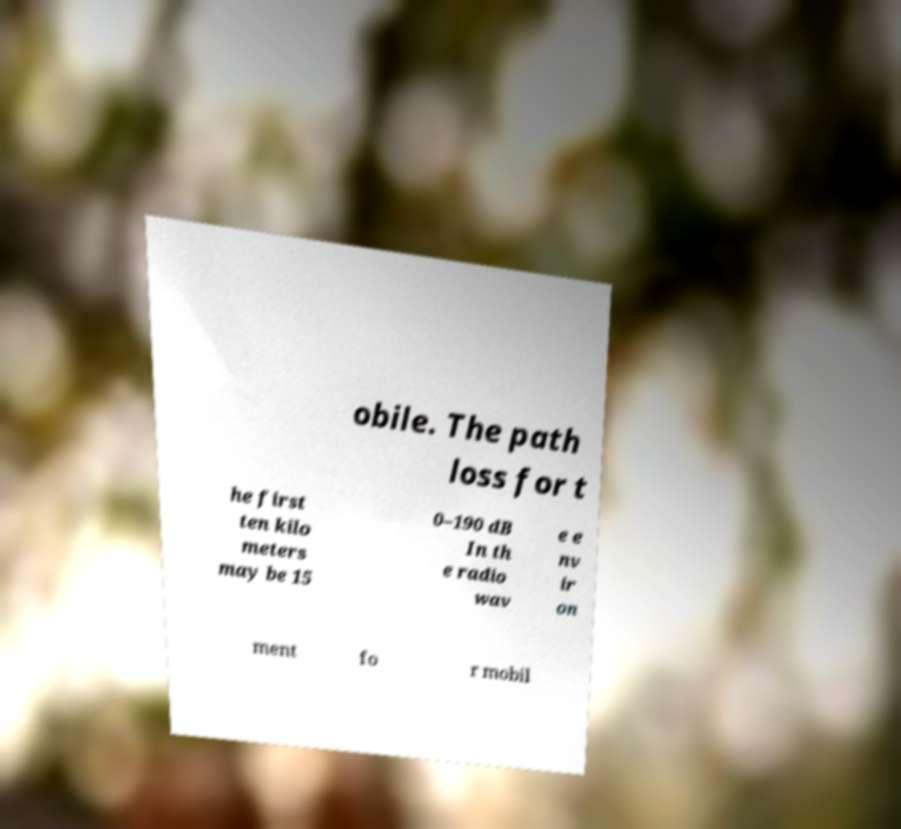Please identify and transcribe the text found in this image. obile. The path loss for t he first ten kilo meters may be 15 0–190 dB In th e radio wav e e nv ir on ment fo r mobil 